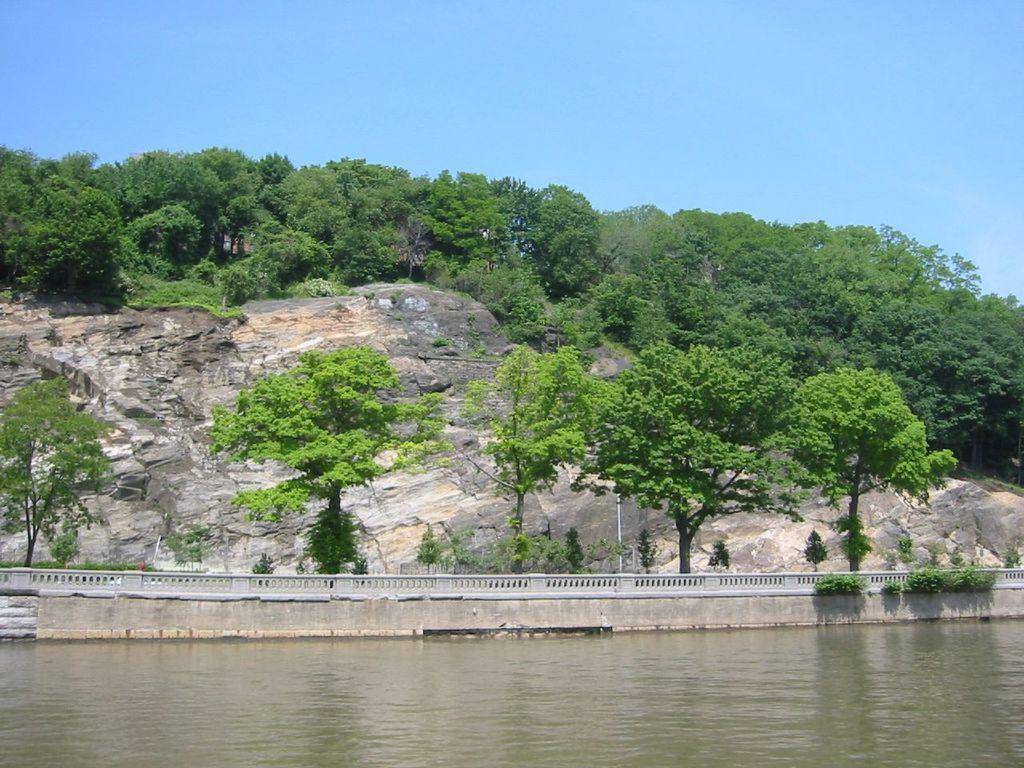What type of vegetation can be seen in the image? There are many trees and plants in the image. What is the tall, vertical object in the image? There is a pole in the image. What type of natural feature can be seen in the image? There are rocks in the image. What type of structure is present in the image? There is railing in the image. What is visible at the bottom of the image? There is water visible at the bottom of the image. What is visible at the top of the image? The sky is visible at the top of the image. What is the taste of the partner in the image? There is no partner present in the image, and therefore no taste can be associated with it. Is there a dock visible in the image? There is no dock present in the image. 